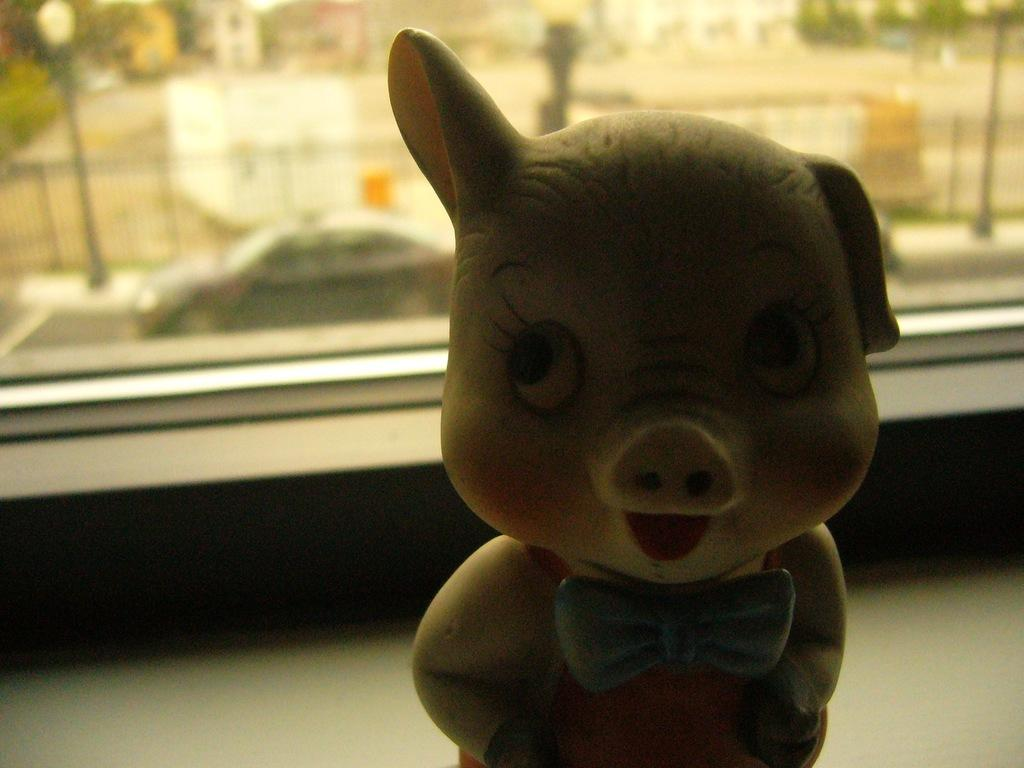What object can be seen in the image that is typically used for play? There is a toy in the image. What type of architectural feature is present in the image? There is a glass window in the image. What can be seen through the window in the image? A vehicle on the road, trees, railing, poles, and buildings are visible through the window. What time is displayed on the clock in the image? There is no clock present in the image. What type of footwear is visible in the image? There is no footwear visible in the image. 